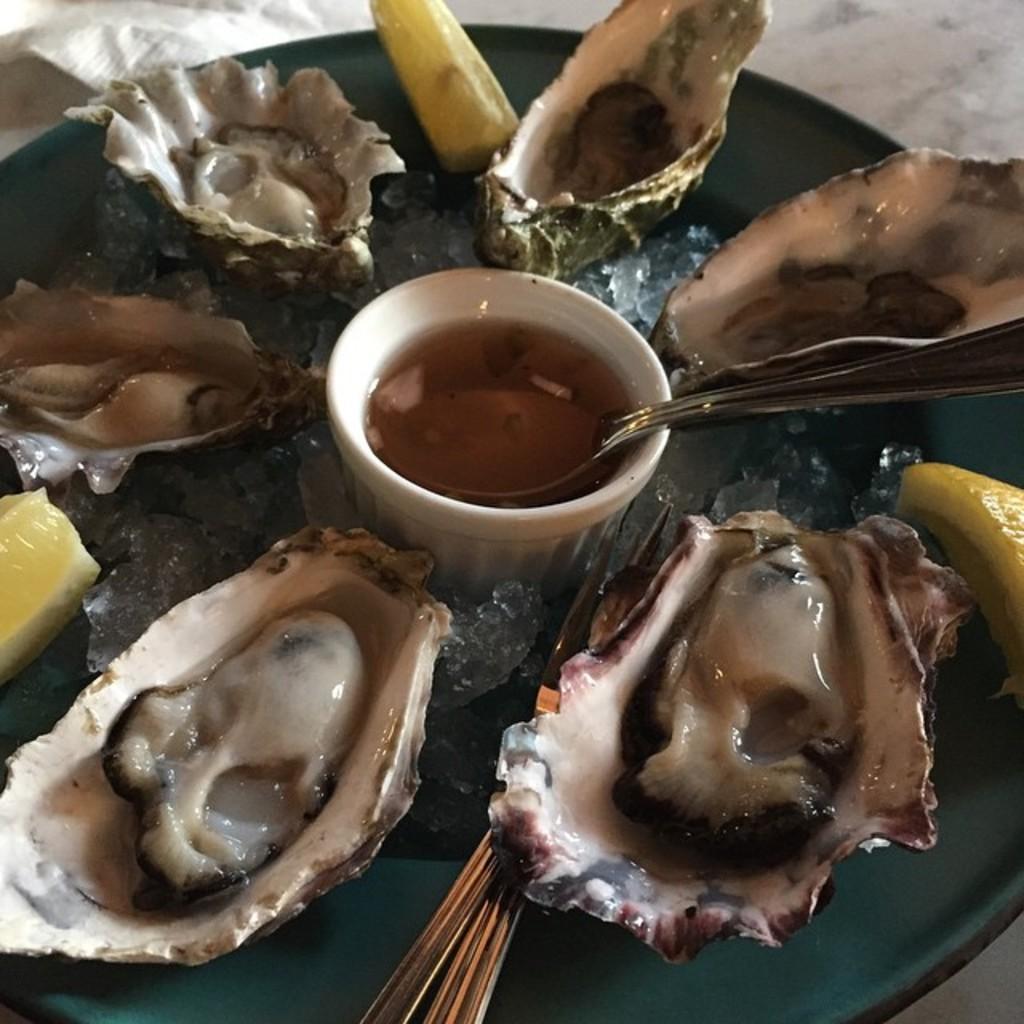Could you give a brief overview of what you see in this image? In this image we can see some seafood on the plate and there is a bowl filled with some liquid. 